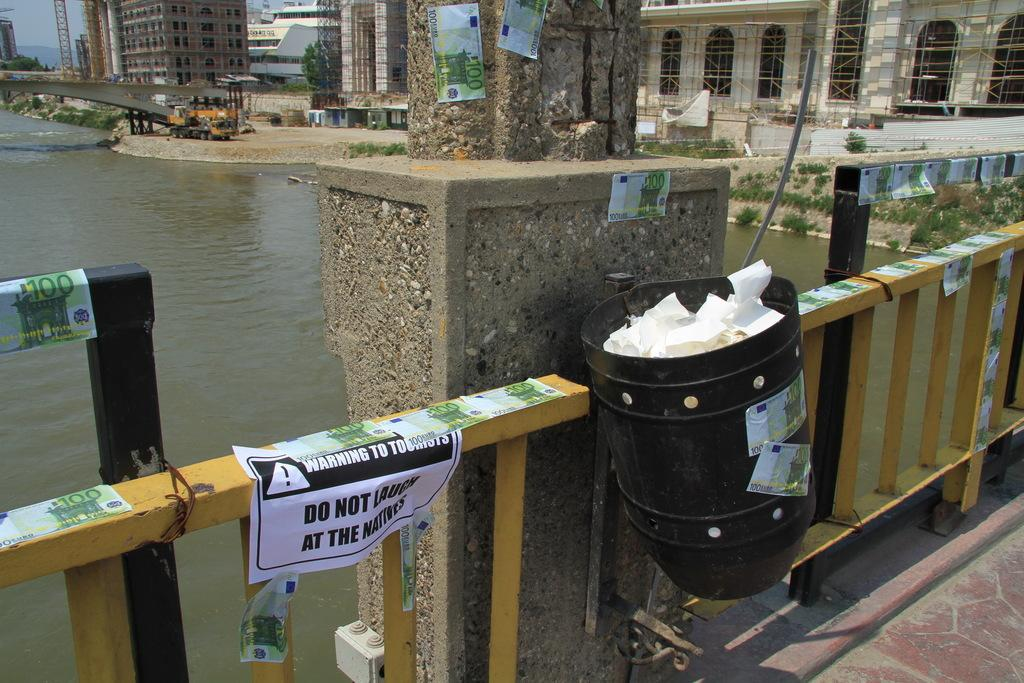<image>
Offer a succinct explanation of the picture presented. A foot bridge over water with a warning sign on the rail saying DO NOT LAUGH AT THE NATIVES.with city in background 